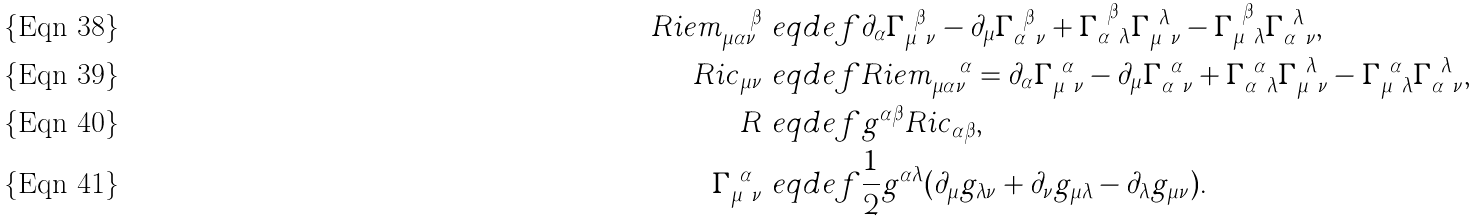<formula> <loc_0><loc_0><loc_500><loc_500>R i e m _ { \mu \alpha \nu } ^ { \quad \beta } & \ e q d e f \partial _ { \alpha } \Gamma _ { \mu \ \nu } ^ { \ \beta } - \partial _ { \mu } \Gamma _ { \alpha \ \nu } ^ { \ \beta } + \Gamma _ { \alpha \ \lambda } ^ { \ \beta } \Gamma _ { \mu \ \nu } ^ { \ \lambda } - \Gamma _ { \mu \ \lambda } ^ { \ \beta } \Gamma _ { \alpha \ \nu } ^ { \ \lambda } , \\ R i c _ { \mu \nu } & \ e q d e f R i e m _ { \mu \alpha \nu } ^ { \quad \alpha } = \partial _ { \alpha } \Gamma _ { \mu \ \nu } ^ { \ \alpha } - \partial _ { \mu } \Gamma _ { \alpha \ \nu } ^ { \ \alpha } + \Gamma _ { \alpha \ \lambda } ^ { \ \alpha } \Gamma _ { \mu \ \nu } ^ { \ \lambda } - \Gamma _ { \mu \ \lambda } ^ { \ \alpha } \Gamma _ { \alpha \ \nu } ^ { \ \lambda } , \\ R & \ e q d e f g ^ { \alpha \beta } R i c _ { \alpha \beta } , \\ \Gamma _ { \mu \ \nu } ^ { \ \alpha } & \ e q d e f \frac { 1 } { 2 } g ^ { \alpha \lambda } ( \partial _ { \mu } g _ { \lambda \nu } + \partial _ { \nu } g _ { \mu \lambda } - \partial _ { \lambda } g _ { \mu \nu } ) .</formula> 